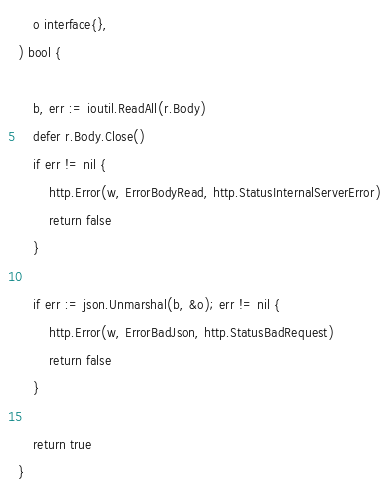<code> <loc_0><loc_0><loc_500><loc_500><_Go_>	o interface{},
) bool {

	b, err := ioutil.ReadAll(r.Body)
	defer r.Body.Close()
	if err != nil {
		http.Error(w, ErrorBodyRead, http.StatusInternalServerError)
		return false
	}

	if err := json.Unmarshal(b, &o); err != nil {
		http.Error(w, ErrorBadJson, http.StatusBadRequest)
		return false
	}

	return true
}
</code> 